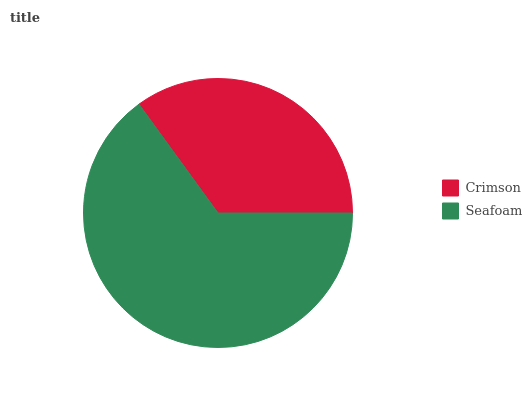Is Crimson the minimum?
Answer yes or no. Yes. Is Seafoam the maximum?
Answer yes or no. Yes. Is Seafoam the minimum?
Answer yes or no. No. Is Seafoam greater than Crimson?
Answer yes or no. Yes. Is Crimson less than Seafoam?
Answer yes or no. Yes. Is Crimson greater than Seafoam?
Answer yes or no. No. Is Seafoam less than Crimson?
Answer yes or no. No. Is Seafoam the high median?
Answer yes or no. Yes. Is Crimson the low median?
Answer yes or no. Yes. Is Crimson the high median?
Answer yes or no. No. Is Seafoam the low median?
Answer yes or no. No. 